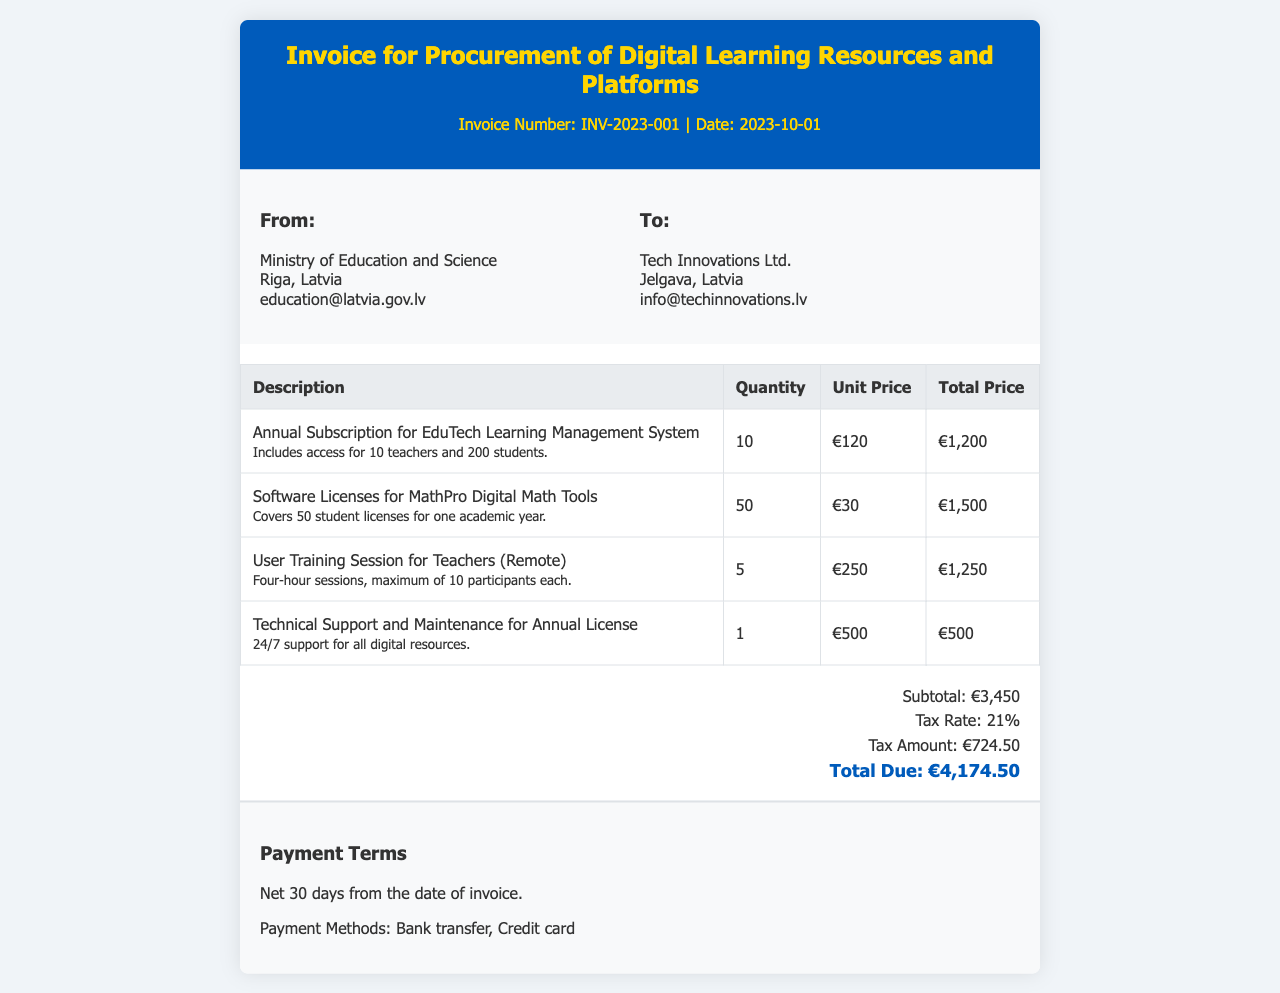What is the invoice number? The invoice number is listed under the invoice title.
Answer: INV-2023-001 What is the total due amount? The total due is provided in the invoice summary section.
Answer: €4,174.50 Who is the recipient of the invoice? The recipient's information is mentioned in the "To" section of the invoice.
Answer: Tech Innovations Ltd What is the unit price for the EduTech Learning Management System? The unit price for the EduTech Learning Management System is detailed in the invoice table.
Answer: €120 How many user training sessions are included in the invoice? The quantity of user training sessions is specified in the invoice table under the training session entry.
Answer: 5 What is the tax amount calculated on the subtotal? The tax amount is included in the invoice summary, indicating its calculation from the subtotal.
Answer: €724.50 What is the payment term stated in the invoice? The payment term is found in the payment terms section of the invoice.
Answer: Net 30 days What software license covers 50 student licenses? This information can be found in the invoice table that lists software licenses.
Answer: MathPro Digital Math Tools What is the subtotal amount before tax? The subtotal amount is explicitly stated in the invoice summary section, before taxes are added.
Answer: €3,450 